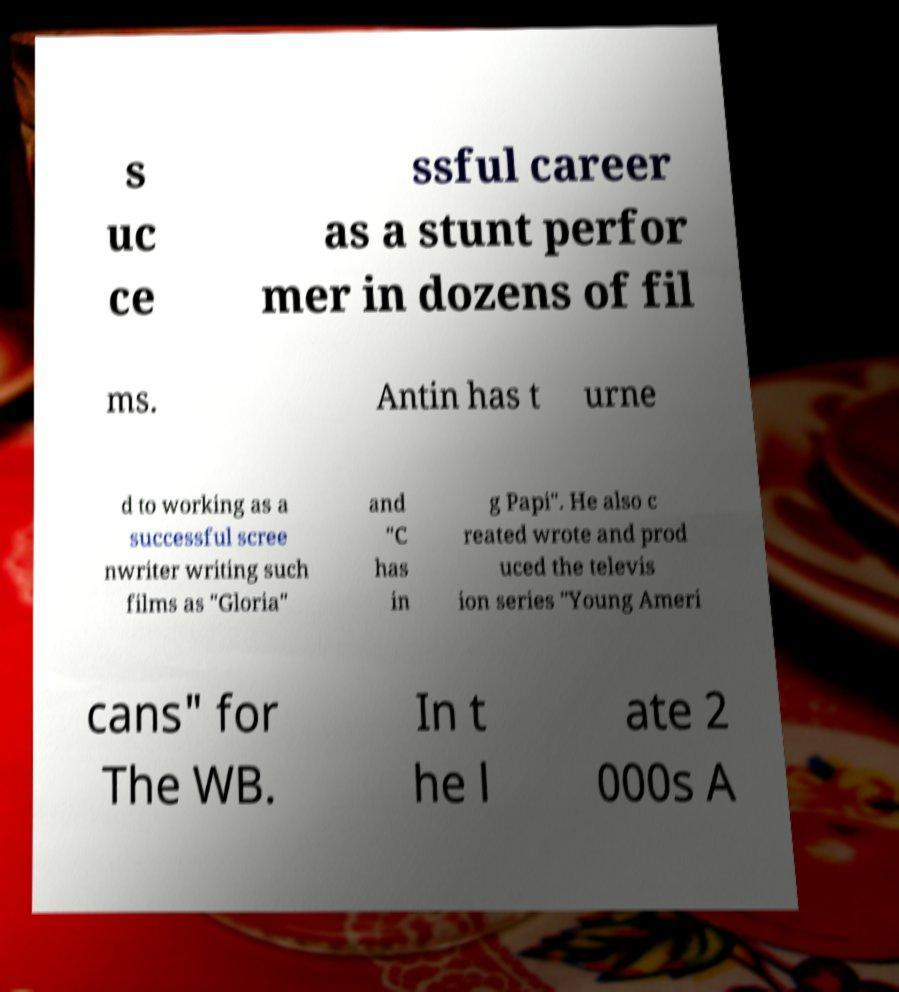Please identify and transcribe the text found in this image. s uc ce ssful career as a stunt perfor mer in dozens of fil ms. Antin has t urne d to working as a successful scree nwriter writing such films as "Gloria" and "C has in g Papi". He also c reated wrote and prod uced the televis ion series "Young Ameri cans" for The WB. In t he l ate 2 000s A 